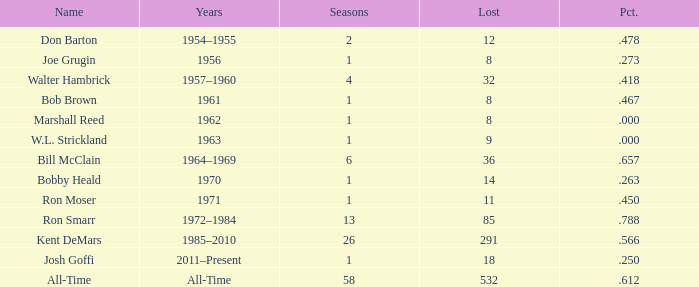Parse the table in full. {'header': ['Name', 'Years', 'Seasons', 'Lost', 'Pct.'], 'rows': [['Don Barton', '1954–1955', '2', '12', '.478'], ['Joe Grugin', '1956', '1', '8', '.273'], ['Walter Hambrick', '1957–1960', '4', '32', '.418'], ['Bob Brown', '1961', '1', '8', '.467'], ['Marshall Reed', '1962', '1', '8', '.000'], ['W.L. Strickland', '1963', '1', '9', '.000'], ['Bill McClain', '1964–1969', '6', '36', '.657'], ['Bobby Heald', '1970', '1', '14', '.263'], ['Ron Moser', '1971', '1', '11', '.450'], ['Ron Smarr', '1972–1984', '13', '85', '.788'], ['Kent DeMars', '1985–2010', '26', '291', '.566'], ['Josh Goffi', '2011–Present', '1', '18', '.250'], ['All-Time', 'All-Time', '58', '532', '.612']]} Which Seasons has a Name of joe grugin, and a Lost larger than 8? 0.0. 